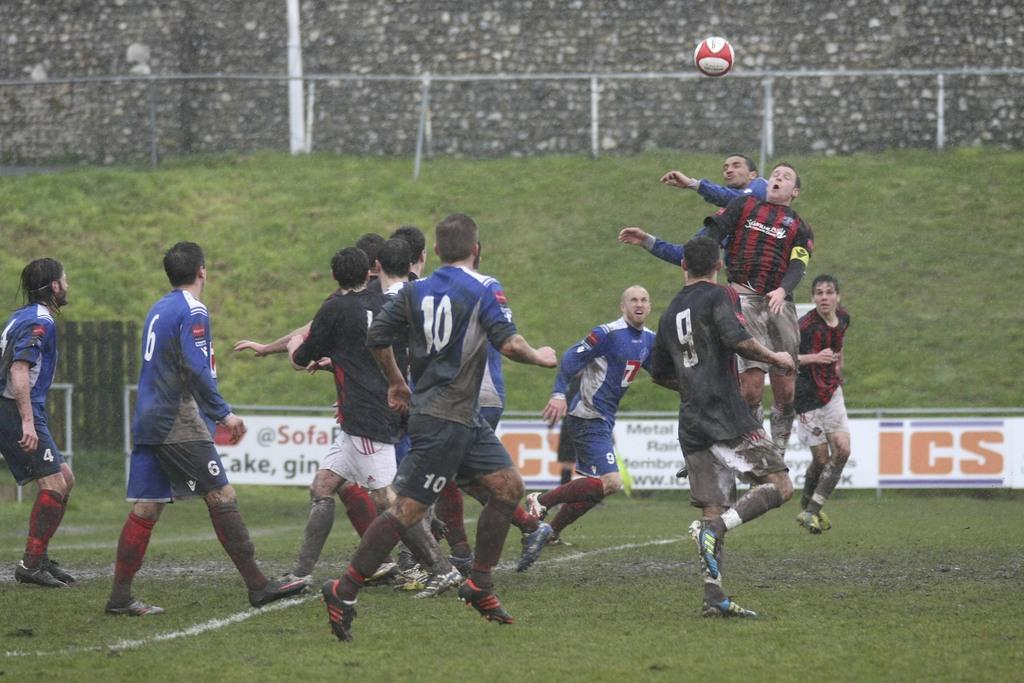<image>
Give a short and clear explanation of the subsequent image. Soccer players play a game in the rain near an ICS sign 